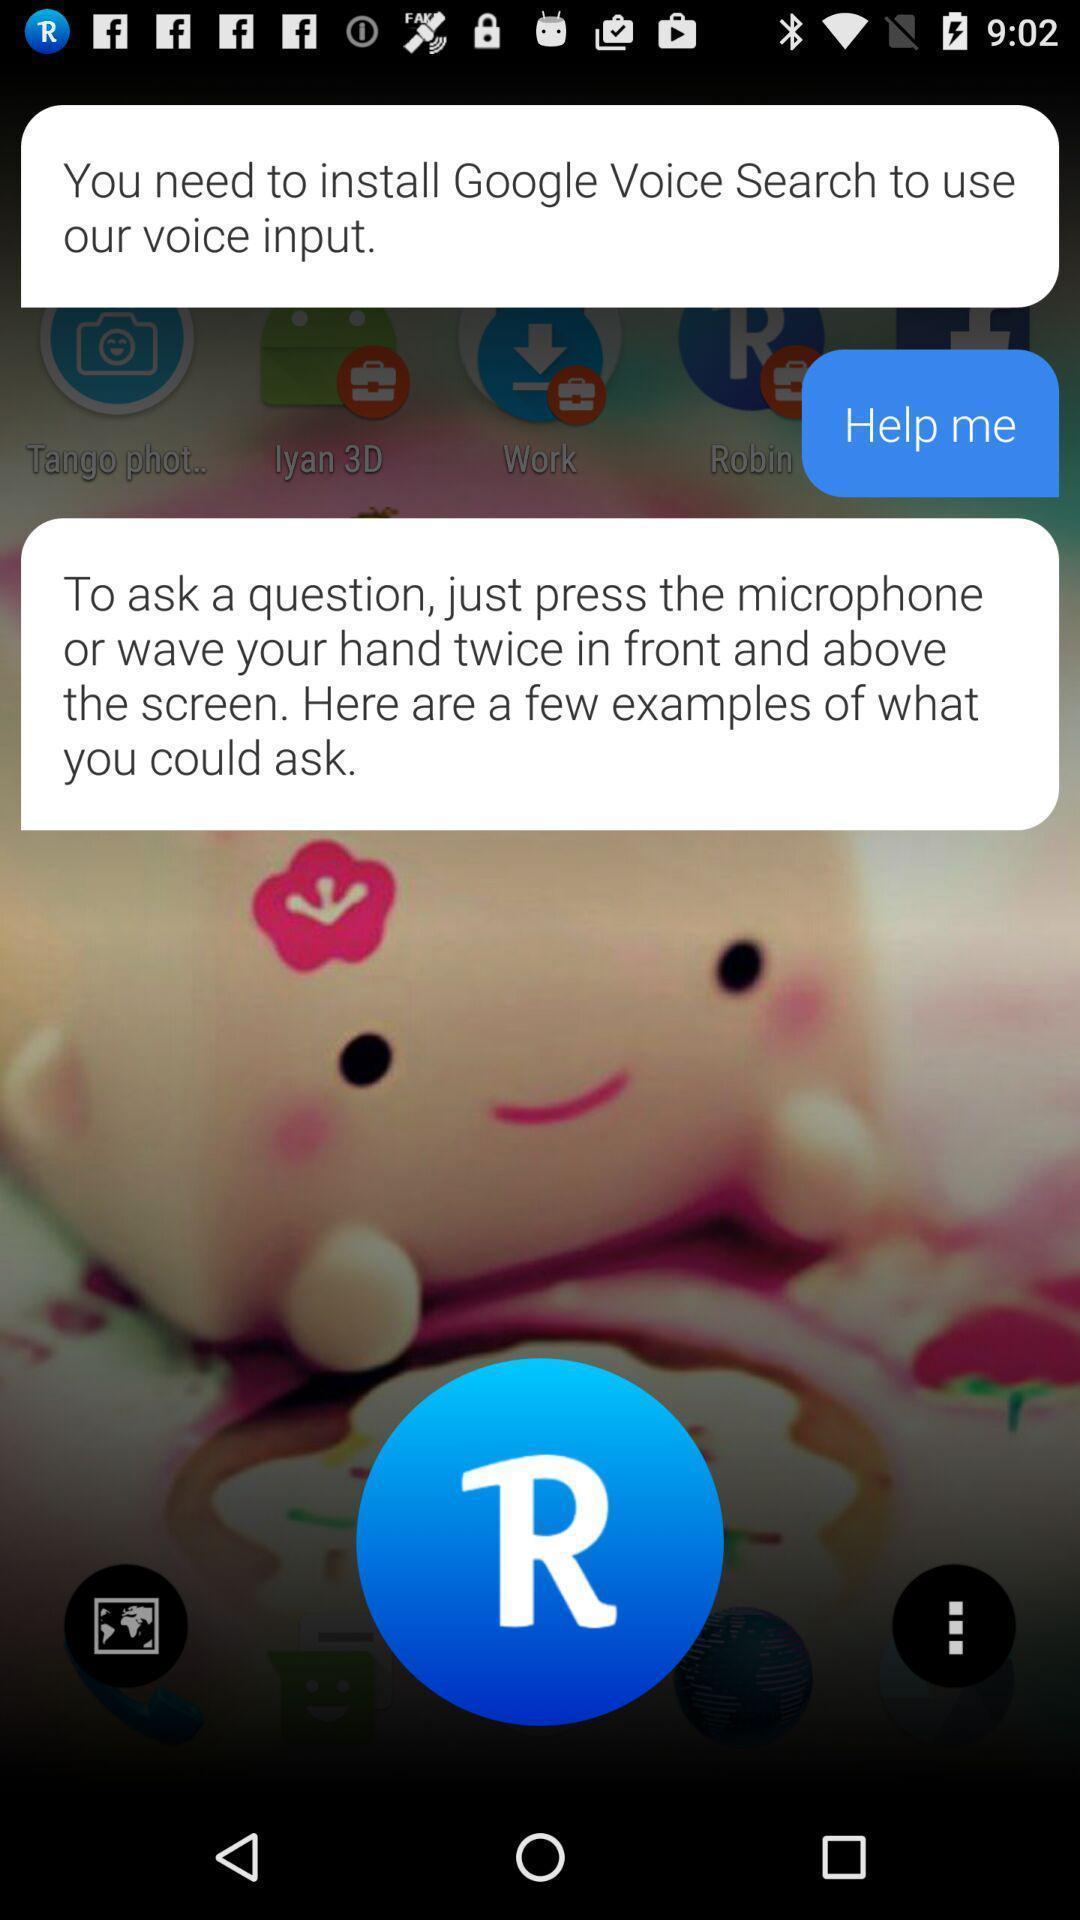Summarize the information in this screenshot. Screen page of a voice assistant app. 